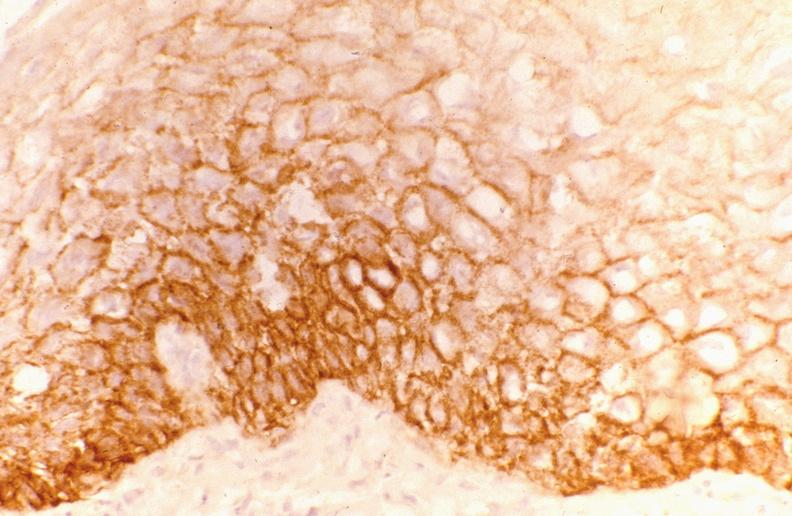does this image show leukoplakia, egf receptor?
Answer the question using a single word or phrase. Yes 